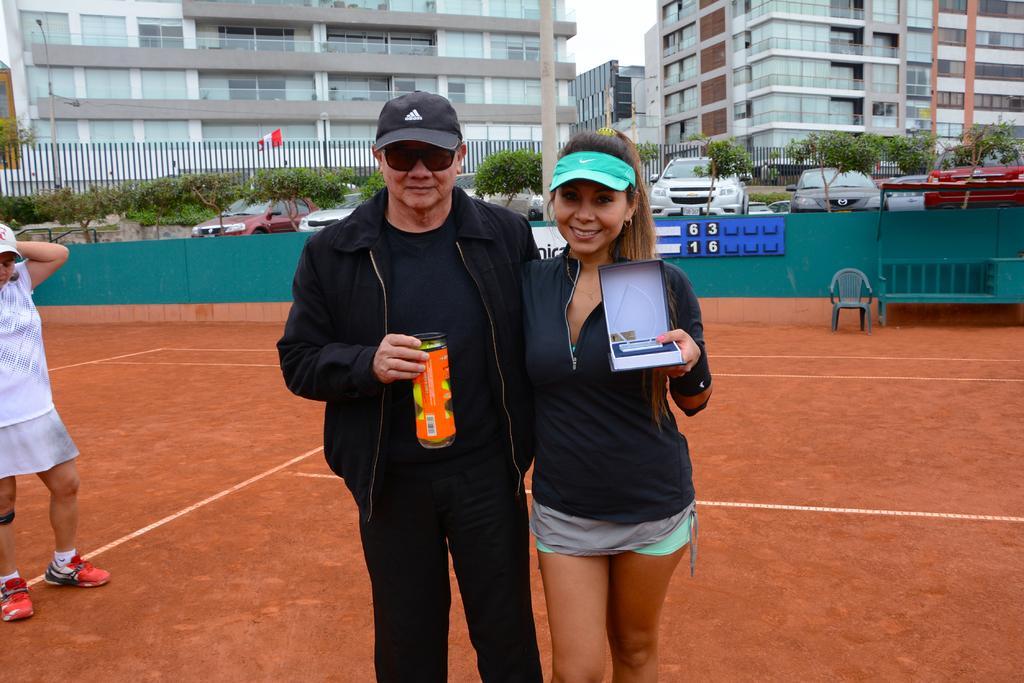How would you summarize this image in a sentence or two? In this picture there is a man wearing black color jacket and holding the orange can in the hand, smiling and giving a pose into the camera. Beside there is a woman, standing and showing boxing. Behind we can see the green color boundary wall and some cars parked. Behind there is a pipe fencing. In the background we can see the glass building. 